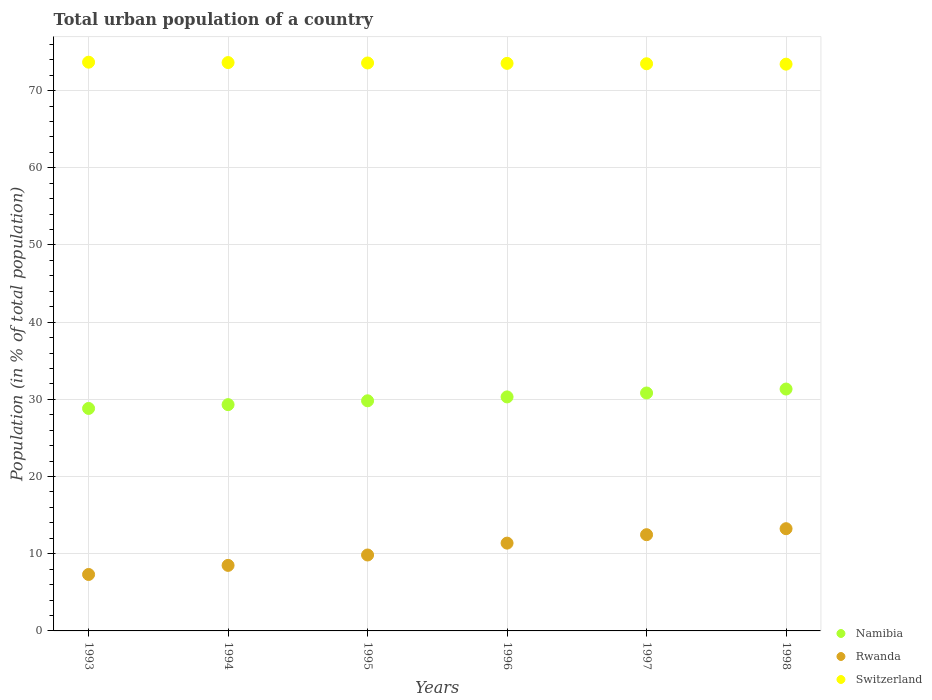Is the number of dotlines equal to the number of legend labels?
Your answer should be very brief. Yes. What is the urban population in Switzerland in 1994?
Ensure brevity in your answer.  73.63. Across all years, what is the maximum urban population in Namibia?
Give a very brief answer. 31.34. Across all years, what is the minimum urban population in Namibia?
Make the answer very short. 28.82. In which year was the urban population in Namibia maximum?
Keep it short and to the point. 1998. In which year was the urban population in Switzerland minimum?
Provide a succinct answer. 1998. What is the total urban population in Namibia in the graph?
Give a very brief answer. 180.43. What is the difference between the urban population in Namibia in 1997 and that in 1998?
Your answer should be compact. -0.51. What is the difference between the urban population in Namibia in 1998 and the urban population in Rwanda in 1995?
Your answer should be compact. 21.5. What is the average urban population in Rwanda per year?
Offer a very short reply. 10.45. In the year 1994, what is the difference between the urban population in Switzerland and urban population in Rwanda?
Give a very brief answer. 65.14. In how many years, is the urban population in Switzerland greater than 72 %?
Ensure brevity in your answer.  6. What is the ratio of the urban population in Namibia in 1994 to that in 1995?
Provide a short and direct response. 0.98. What is the difference between the highest and the second highest urban population in Switzerland?
Offer a very short reply. 0.05. What is the difference between the highest and the lowest urban population in Rwanda?
Provide a succinct answer. 5.93. In how many years, is the urban population in Namibia greater than the average urban population in Namibia taken over all years?
Give a very brief answer. 3. Is the sum of the urban population in Switzerland in 1994 and 1996 greater than the maximum urban population in Rwanda across all years?
Offer a terse response. Yes. Does the urban population in Switzerland monotonically increase over the years?
Your answer should be very brief. No. How many years are there in the graph?
Provide a succinct answer. 6. What is the difference between two consecutive major ticks on the Y-axis?
Give a very brief answer. 10. Does the graph contain any zero values?
Keep it short and to the point. No. Where does the legend appear in the graph?
Give a very brief answer. Bottom right. How are the legend labels stacked?
Provide a short and direct response. Vertical. What is the title of the graph?
Your answer should be very brief. Total urban population of a country. What is the label or title of the Y-axis?
Ensure brevity in your answer.  Population (in % of total population). What is the Population (in % of total population) of Namibia in 1993?
Make the answer very short. 28.82. What is the Population (in % of total population) of Rwanda in 1993?
Your answer should be compact. 7.31. What is the Population (in % of total population) of Switzerland in 1993?
Give a very brief answer. 73.68. What is the Population (in % of total population) in Namibia in 1994?
Offer a very short reply. 29.32. What is the Population (in % of total population) of Rwanda in 1994?
Your answer should be very brief. 8.49. What is the Population (in % of total population) of Switzerland in 1994?
Your answer should be very brief. 73.63. What is the Population (in % of total population) of Namibia in 1995?
Provide a short and direct response. 29.81. What is the Population (in % of total population) in Rwanda in 1995?
Make the answer very short. 9.84. What is the Population (in % of total population) in Switzerland in 1995?
Provide a succinct answer. 73.58. What is the Population (in % of total population) of Namibia in 1996?
Offer a terse response. 30.32. What is the Population (in % of total population) of Rwanda in 1996?
Offer a very short reply. 11.37. What is the Population (in % of total population) in Switzerland in 1996?
Give a very brief answer. 73.53. What is the Population (in % of total population) in Namibia in 1997?
Your answer should be very brief. 30.82. What is the Population (in % of total population) in Rwanda in 1997?
Make the answer very short. 12.47. What is the Population (in % of total population) in Switzerland in 1997?
Offer a terse response. 73.48. What is the Population (in % of total population) of Namibia in 1998?
Your response must be concise. 31.34. What is the Population (in % of total population) in Rwanda in 1998?
Give a very brief answer. 13.24. What is the Population (in % of total population) in Switzerland in 1998?
Offer a very short reply. 73.42. Across all years, what is the maximum Population (in % of total population) of Namibia?
Offer a very short reply. 31.34. Across all years, what is the maximum Population (in % of total population) of Rwanda?
Ensure brevity in your answer.  13.24. Across all years, what is the maximum Population (in % of total population) in Switzerland?
Give a very brief answer. 73.68. Across all years, what is the minimum Population (in % of total population) of Namibia?
Your answer should be compact. 28.82. Across all years, what is the minimum Population (in % of total population) of Rwanda?
Provide a short and direct response. 7.31. Across all years, what is the minimum Population (in % of total population) in Switzerland?
Ensure brevity in your answer.  73.42. What is the total Population (in % of total population) of Namibia in the graph?
Give a very brief answer. 180.43. What is the total Population (in % of total population) of Rwanda in the graph?
Ensure brevity in your answer.  62.72. What is the total Population (in % of total population) in Switzerland in the graph?
Your answer should be very brief. 441.31. What is the difference between the Population (in % of total population) of Namibia in 1993 and that in 1994?
Offer a terse response. -0.49. What is the difference between the Population (in % of total population) in Rwanda in 1993 and that in 1994?
Offer a very short reply. -1.18. What is the difference between the Population (in % of total population) of Namibia in 1993 and that in 1995?
Your answer should be compact. -0.99. What is the difference between the Population (in % of total population) of Rwanda in 1993 and that in 1995?
Give a very brief answer. -2.52. What is the difference between the Population (in % of total population) of Switzerland in 1993 and that in 1995?
Offer a very short reply. 0.1. What is the difference between the Population (in % of total population) of Namibia in 1993 and that in 1996?
Your response must be concise. -1.49. What is the difference between the Population (in % of total population) of Rwanda in 1993 and that in 1996?
Keep it short and to the point. -4.06. What is the difference between the Population (in % of total population) of Switzerland in 1993 and that in 1996?
Keep it short and to the point. 0.15. What is the difference between the Population (in % of total population) of Namibia in 1993 and that in 1997?
Provide a succinct answer. -2. What is the difference between the Population (in % of total population) of Rwanda in 1993 and that in 1997?
Provide a short and direct response. -5.15. What is the difference between the Population (in % of total population) of Switzerland in 1993 and that in 1997?
Make the answer very short. 0.2. What is the difference between the Population (in % of total population) of Namibia in 1993 and that in 1998?
Provide a short and direct response. -2.51. What is the difference between the Population (in % of total population) in Rwanda in 1993 and that in 1998?
Provide a short and direct response. -5.93. What is the difference between the Population (in % of total population) of Switzerland in 1993 and that in 1998?
Your answer should be compact. 0.26. What is the difference between the Population (in % of total population) in Namibia in 1994 and that in 1995?
Offer a very short reply. -0.5. What is the difference between the Population (in % of total population) of Rwanda in 1994 and that in 1995?
Your answer should be very brief. -1.35. What is the difference between the Population (in % of total population) in Switzerland in 1994 and that in 1995?
Ensure brevity in your answer.  0.05. What is the difference between the Population (in % of total population) in Rwanda in 1994 and that in 1996?
Your response must be concise. -2.88. What is the difference between the Population (in % of total population) in Switzerland in 1994 and that in 1996?
Offer a very short reply. 0.1. What is the difference between the Population (in % of total population) of Namibia in 1994 and that in 1997?
Your answer should be compact. -1.51. What is the difference between the Population (in % of total population) in Rwanda in 1994 and that in 1997?
Your answer should be compact. -3.98. What is the difference between the Population (in % of total population) in Switzerland in 1994 and that in 1997?
Offer a very short reply. 0.15. What is the difference between the Population (in % of total population) in Namibia in 1994 and that in 1998?
Make the answer very short. -2.02. What is the difference between the Population (in % of total population) of Rwanda in 1994 and that in 1998?
Ensure brevity in your answer.  -4.75. What is the difference between the Population (in % of total population) in Switzerland in 1994 and that in 1998?
Keep it short and to the point. 0.2. What is the difference between the Population (in % of total population) of Namibia in 1995 and that in 1996?
Offer a very short reply. -0.5. What is the difference between the Population (in % of total population) of Rwanda in 1995 and that in 1996?
Offer a terse response. -1.54. What is the difference between the Population (in % of total population) of Switzerland in 1995 and that in 1996?
Your answer should be very brief. 0.05. What is the difference between the Population (in % of total population) in Namibia in 1995 and that in 1997?
Offer a very short reply. -1.01. What is the difference between the Population (in % of total population) of Rwanda in 1995 and that in 1997?
Ensure brevity in your answer.  -2.63. What is the difference between the Population (in % of total population) in Switzerland in 1995 and that in 1997?
Offer a very short reply. 0.1. What is the difference between the Population (in % of total population) of Namibia in 1995 and that in 1998?
Provide a succinct answer. -1.52. What is the difference between the Population (in % of total population) in Rwanda in 1995 and that in 1998?
Offer a terse response. -3.41. What is the difference between the Population (in % of total population) of Switzerland in 1995 and that in 1998?
Make the answer very short. 0.15. What is the difference between the Population (in % of total population) of Namibia in 1996 and that in 1997?
Ensure brevity in your answer.  -0.51. What is the difference between the Population (in % of total population) in Rwanda in 1996 and that in 1997?
Make the answer very short. -1.09. What is the difference between the Population (in % of total population) of Switzerland in 1996 and that in 1997?
Ensure brevity in your answer.  0.05. What is the difference between the Population (in % of total population) in Namibia in 1996 and that in 1998?
Keep it short and to the point. -1.02. What is the difference between the Population (in % of total population) of Rwanda in 1996 and that in 1998?
Provide a short and direct response. -1.87. What is the difference between the Population (in % of total population) of Switzerland in 1996 and that in 1998?
Ensure brevity in your answer.  0.1. What is the difference between the Population (in % of total population) in Namibia in 1997 and that in 1998?
Provide a short and direct response. -0.51. What is the difference between the Population (in % of total population) of Rwanda in 1997 and that in 1998?
Offer a very short reply. -0.78. What is the difference between the Population (in % of total population) of Switzerland in 1997 and that in 1998?
Your answer should be very brief. 0.05. What is the difference between the Population (in % of total population) in Namibia in 1993 and the Population (in % of total population) in Rwanda in 1994?
Provide a succinct answer. 20.33. What is the difference between the Population (in % of total population) in Namibia in 1993 and the Population (in % of total population) in Switzerland in 1994?
Provide a short and direct response. -44.81. What is the difference between the Population (in % of total population) of Rwanda in 1993 and the Population (in % of total population) of Switzerland in 1994?
Make the answer very short. -66.32. What is the difference between the Population (in % of total population) of Namibia in 1993 and the Population (in % of total population) of Rwanda in 1995?
Offer a terse response. 18.99. What is the difference between the Population (in % of total population) of Namibia in 1993 and the Population (in % of total population) of Switzerland in 1995?
Provide a short and direct response. -44.76. What is the difference between the Population (in % of total population) of Rwanda in 1993 and the Population (in % of total population) of Switzerland in 1995?
Offer a very short reply. -66.27. What is the difference between the Population (in % of total population) in Namibia in 1993 and the Population (in % of total population) in Rwanda in 1996?
Your response must be concise. 17.45. What is the difference between the Population (in % of total population) of Namibia in 1993 and the Population (in % of total population) of Switzerland in 1996?
Make the answer very short. -44.7. What is the difference between the Population (in % of total population) of Rwanda in 1993 and the Population (in % of total population) of Switzerland in 1996?
Give a very brief answer. -66.21. What is the difference between the Population (in % of total population) of Namibia in 1993 and the Population (in % of total population) of Rwanda in 1997?
Offer a very short reply. 16.36. What is the difference between the Population (in % of total population) in Namibia in 1993 and the Population (in % of total population) in Switzerland in 1997?
Your answer should be compact. -44.65. What is the difference between the Population (in % of total population) in Rwanda in 1993 and the Population (in % of total population) in Switzerland in 1997?
Offer a very short reply. -66.16. What is the difference between the Population (in % of total population) in Namibia in 1993 and the Population (in % of total population) in Rwanda in 1998?
Make the answer very short. 15.58. What is the difference between the Population (in % of total population) in Namibia in 1993 and the Population (in % of total population) in Switzerland in 1998?
Offer a very short reply. -44.6. What is the difference between the Population (in % of total population) of Rwanda in 1993 and the Population (in % of total population) of Switzerland in 1998?
Ensure brevity in your answer.  -66.11. What is the difference between the Population (in % of total population) in Namibia in 1994 and the Population (in % of total population) in Rwanda in 1995?
Offer a terse response. 19.48. What is the difference between the Population (in % of total population) in Namibia in 1994 and the Population (in % of total population) in Switzerland in 1995?
Offer a very short reply. -44.26. What is the difference between the Population (in % of total population) of Rwanda in 1994 and the Population (in % of total population) of Switzerland in 1995?
Your answer should be compact. -65.09. What is the difference between the Population (in % of total population) of Namibia in 1994 and the Population (in % of total population) of Rwanda in 1996?
Your answer should be very brief. 17.94. What is the difference between the Population (in % of total population) of Namibia in 1994 and the Population (in % of total population) of Switzerland in 1996?
Provide a succinct answer. -44.21. What is the difference between the Population (in % of total population) of Rwanda in 1994 and the Population (in % of total population) of Switzerland in 1996?
Give a very brief answer. -65.04. What is the difference between the Population (in % of total population) in Namibia in 1994 and the Population (in % of total population) in Rwanda in 1997?
Offer a terse response. 16.85. What is the difference between the Population (in % of total population) of Namibia in 1994 and the Population (in % of total population) of Switzerland in 1997?
Offer a terse response. -44.16. What is the difference between the Population (in % of total population) in Rwanda in 1994 and the Population (in % of total population) in Switzerland in 1997?
Ensure brevity in your answer.  -64.99. What is the difference between the Population (in % of total population) of Namibia in 1994 and the Population (in % of total population) of Rwanda in 1998?
Make the answer very short. 16.07. What is the difference between the Population (in % of total population) in Namibia in 1994 and the Population (in % of total population) in Switzerland in 1998?
Your answer should be very brief. -44.11. What is the difference between the Population (in % of total population) in Rwanda in 1994 and the Population (in % of total population) in Switzerland in 1998?
Your answer should be compact. -64.93. What is the difference between the Population (in % of total population) in Namibia in 1995 and the Population (in % of total population) in Rwanda in 1996?
Give a very brief answer. 18.44. What is the difference between the Population (in % of total population) of Namibia in 1995 and the Population (in % of total population) of Switzerland in 1996?
Make the answer very short. -43.71. What is the difference between the Population (in % of total population) of Rwanda in 1995 and the Population (in % of total population) of Switzerland in 1996?
Your answer should be compact. -63.69. What is the difference between the Population (in % of total population) of Namibia in 1995 and the Population (in % of total population) of Rwanda in 1997?
Your response must be concise. 17.35. What is the difference between the Population (in % of total population) in Namibia in 1995 and the Population (in % of total population) in Switzerland in 1997?
Ensure brevity in your answer.  -43.66. What is the difference between the Population (in % of total population) of Rwanda in 1995 and the Population (in % of total population) of Switzerland in 1997?
Your answer should be very brief. -63.64. What is the difference between the Population (in % of total population) in Namibia in 1995 and the Population (in % of total population) in Rwanda in 1998?
Ensure brevity in your answer.  16.57. What is the difference between the Population (in % of total population) in Namibia in 1995 and the Population (in % of total population) in Switzerland in 1998?
Your answer should be very brief. -43.61. What is the difference between the Population (in % of total population) in Rwanda in 1995 and the Population (in % of total population) in Switzerland in 1998?
Your answer should be very brief. -63.59. What is the difference between the Population (in % of total population) of Namibia in 1996 and the Population (in % of total population) of Rwanda in 1997?
Offer a very short reply. 17.85. What is the difference between the Population (in % of total population) in Namibia in 1996 and the Population (in % of total population) in Switzerland in 1997?
Your answer should be compact. -43.16. What is the difference between the Population (in % of total population) in Rwanda in 1996 and the Population (in % of total population) in Switzerland in 1997?
Your answer should be very brief. -62.1. What is the difference between the Population (in % of total population) of Namibia in 1996 and the Population (in % of total population) of Rwanda in 1998?
Your answer should be very brief. 17.07. What is the difference between the Population (in % of total population) in Namibia in 1996 and the Population (in % of total population) in Switzerland in 1998?
Give a very brief answer. -43.11. What is the difference between the Population (in % of total population) in Rwanda in 1996 and the Population (in % of total population) in Switzerland in 1998?
Your answer should be very brief. -62.05. What is the difference between the Population (in % of total population) in Namibia in 1997 and the Population (in % of total population) in Rwanda in 1998?
Ensure brevity in your answer.  17.58. What is the difference between the Population (in % of total population) in Namibia in 1997 and the Population (in % of total population) in Switzerland in 1998?
Your response must be concise. -42.6. What is the difference between the Population (in % of total population) in Rwanda in 1997 and the Population (in % of total population) in Switzerland in 1998?
Your answer should be very brief. -60.96. What is the average Population (in % of total population) of Namibia per year?
Make the answer very short. 30.07. What is the average Population (in % of total population) of Rwanda per year?
Your answer should be very brief. 10.45. What is the average Population (in % of total population) in Switzerland per year?
Make the answer very short. 73.55. In the year 1993, what is the difference between the Population (in % of total population) in Namibia and Population (in % of total population) in Rwanda?
Provide a short and direct response. 21.51. In the year 1993, what is the difference between the Population (in % of total population) of Namibia and Population (in % of total population) of Switzerland?
Offer a very short reply. -44.86. In the year 1993, what is the difference between the Population (in % of total population) in Rwanda and Population (in % of total population) in Switzerland?
Your response must be concise. -66.37. In the year 1994, what is the difference between the Population (in % of total population) of Namibia and Population (in % of total population) of Rwanda?
Your answer should be compact. 20.83. In the year 1994, what is the difference between the Population (in % of total population) of Namibia and Population (in % of total population) of Switzerland?
Provide a succinct answer. -44.31. In the year 1994, what is the difference between the Population (in % of total population) in Rwanda and Population (in % of total population) in Switzerland?
Your response must be concise. -65.14. In the year 1995, what is the difference between the Population (in % of total population) of Namibia and Population (in % of total population) of Rwanda?
Keep it short and to the point. 19.98. In the year 1995, what is the difference between the Population (in % of total population) of Namibia and Population (in % of total population) of Switzerland?
Your response must be concise. -43.77. In the year 1995, what is the difference between the Population (in % of total population) in Rwanda and Population (in % of total population) in Switzerland?
Provide a succinct answer. -63.74. In the year 1996, what is the difference between the Population (in % of total population) in Namibia and Population (in % of total population) in Rwanda?
Provide a succinct answer. 18.94. In the year 1996, what is the difference between the Population (in % of total population) of Namibia and Population (in % of total population) of Switzerland?
Your answer should be compact. -43.21. In the year 1996, what is the difference between the Population (in % of total population) in Rwanda and Population (in % of total population) in Switzerland?
Ensure brevity in your answer.  -62.15. In the year 1997, what is the difference between the Population (in % of total population) in Namibia and Population (in % of total population) in Rwanda?
Your answer should be very brief. 18.36. In the year 1997, what is the difference between the Population (in % of total population) in Namibia and Population (in % of total population) in Switzerland?
Your answer should be very brief. -42.65. In the year 1997, what is the difference between the Population (in % of total population) of Rwanda and Population (in % of total population) of Switzerland?
Keep it short and to the point. -61.01. In the year 1998, what is the difference between the Population (in % of total population) in Namibia and Population (in % of total population) in Rwanda?
Ensure brevity in your answer.  18.09. In the year 1998, what is the difference between the Population (in % of total population) in Namibia and Population (in % of total population) in Switzerland?
Provide a succinct answer. -42.09. In the year 1998, what is the difference between the Population (in % of total population) in Rwanda and Population (in % of total population) in Switzerland?
Keep it short and to the point. -60.18. What is the ratio of the Population (in % of total population) in Namibia in 1993 to that in 1994?
Keep it short and to the point. 0.98. What is the ratio of the Population (in % of total population) of Rwanda in 1993 to that in 1994?
Ensure brevity in your answer.  0.86. What is the ratio of the Population (in % of total population) in Namibia in 1993 to that in 1995?
Make the answer very short. 0.97. What is the ratio of the Population (in % of total population) in Rwanda in 1993 to that in 1995?
Make the answer very short. 0.74. What is the ratio of the Population (in % of total population) of Namibia in 1993 to that in 1996?
Ensure brevity in your answer.  0.95. What is the ratio of the Population (in % of total population) in Rwanda in 1993 to that in 1996?
Keep it short and to the point. 0.64. What is the ratio of the Population (in % of total population) in Switzerland in 1993 to that in 1996?
Provide a short and direct response. 1. What is the ratio of the Population (in % of total population) in Namibia in 1993 to that in 1997?
Your answer should be compact. 0.94. What is the ratio of the Population (in % of total population) in Rwanda in 1993 to that in 1997?
Your answer should be compact. 0.59. What is the ratio of the Population (in % of total population) in Switzerland in 1993 to that in 1997?
Your answer should be compact. 1. What is the ratio of the Population (in % of total population) in Namibia in 1993 to that in 1998?
Provide a short and direct response. 0.92. What is the ratio of the Population (in % of total population) of Rwanda in 1993 to that in 1998?
Provide a succinct answer. 0.55. What is the ratio of the Population (in % of total population) in Switzerland in 1993 to that in 1998?
Your response must be concise. 1. What is the ratio of the Population (in % of total population) of Namibia in 1994 to that in 1995?
Provide a short and direct response. 0.98. What is the ratio of the Population (in % of total population) in Rwanda in 1994 to that in 1995?
Your answer should be compact. 0.86. What is the ratio of the Population (in % of total population) of Rwanda in 1994 to that in 1996?
Offer a very short reply. 0.75. What is the ratio of the Population (in % of total population) in Namibia in 1994 to that in 1997?
Your response must be concise. 0.95. What is the ratio of the Population (in % of total population) of Rwanda in 1994 to that in 1997?
Keep it short and to the point. 0.68. What is the ratio of the Population (in % of total population) of Namibia in 1994 to that in 1998?
Give a very brief answer. 0.94. What is the ratio of the Population (in % of total population) in Rwanda in 1994 to that in 1998?
Your answer should be very brief. 0.64. What is the ratio of the Population (in % of total population) in Switzerland in 1994 to that in 1998?
Your answer should be compact. 1. What is the ratio of the Population (in % of total population) in Namibia in 1995 to that in 1996?
Offer a terse response. 0.98. What is the ratio of the Population (in % of total population) in Rwanda in 1995 to that in 1996?
Give a very brief answer. 0.86. What is the ratio of the Population (in % of total population) of Switzerland in 1995 to that in 1996?
Ensure brevity in your answer.  1. What is the ratio of the Population (in % of total population) in Namibia in 1995 to that in 1997?
Give a very brief answer. 0.97. What is the ratio of the Population (in % of total population) in Rwanda in 1995 to that in 1997?
Your response must be concise. 0.79. What is the ratio of the Population (in % of total population) in Namibia in 1995 to that in 1998?
Offer a terse response. 0.95. What is the ratio of the Population (in % of total population) in Rwanda in 1995 to that in 1998?
Keep it short and to the point. 0.74. What is the ratio of the Population (in % of total population) of Namibia in 1996 to that in 1997?
Provide a short and direct response. 0.98. What is the ratio of the Population (in % of total population) of Rwanda in 1996 to that in 1997?
Keep it short and to the point. 0.91. What is the ratio of the Population (in % of total population) of Namibia in 1996 to that in 1998?
Provide a short and direct response. 0.97. What is the ratio of the Population (in % of total population) of Rwanda in 1996 to that in 1998?
Ensure brevity in your answer.  0.86. What is the ratio of the Population (in % of total population) in Switzerland in 1996 to that in 1998?
Make the answer very short. 1. What is the ratio of the Population (in % of total population) in Namibia in 1997 to that in 1998?
Provide a short and direct response. 0.98. What is the ratio of the Population (in % of total population) in Rwanda in 1997 to that in 1998?
Offer a very short reply. 0.94. What is the difference between the highest and the second highest Population (in % of total population) in Namibia?
Provide a short and direct response. 0.51. What is the difference between the highest and the second highest Population (in % of total population) in Rwanda?
Provide a short and direct response. 0.78. What is the difference between the highest and the lowest Population (in % of total population) in Namibia?
Provide a succinct answer. 2.51. What is the difference between the highest and the lowest Population (in % of total population) in Rwanda?
Offer a very short reply. 5.93. What is the difference between the highest and the lowest Population (in % of total population) of Switzerland?
Ensure brevity in your answer.  0.26. 